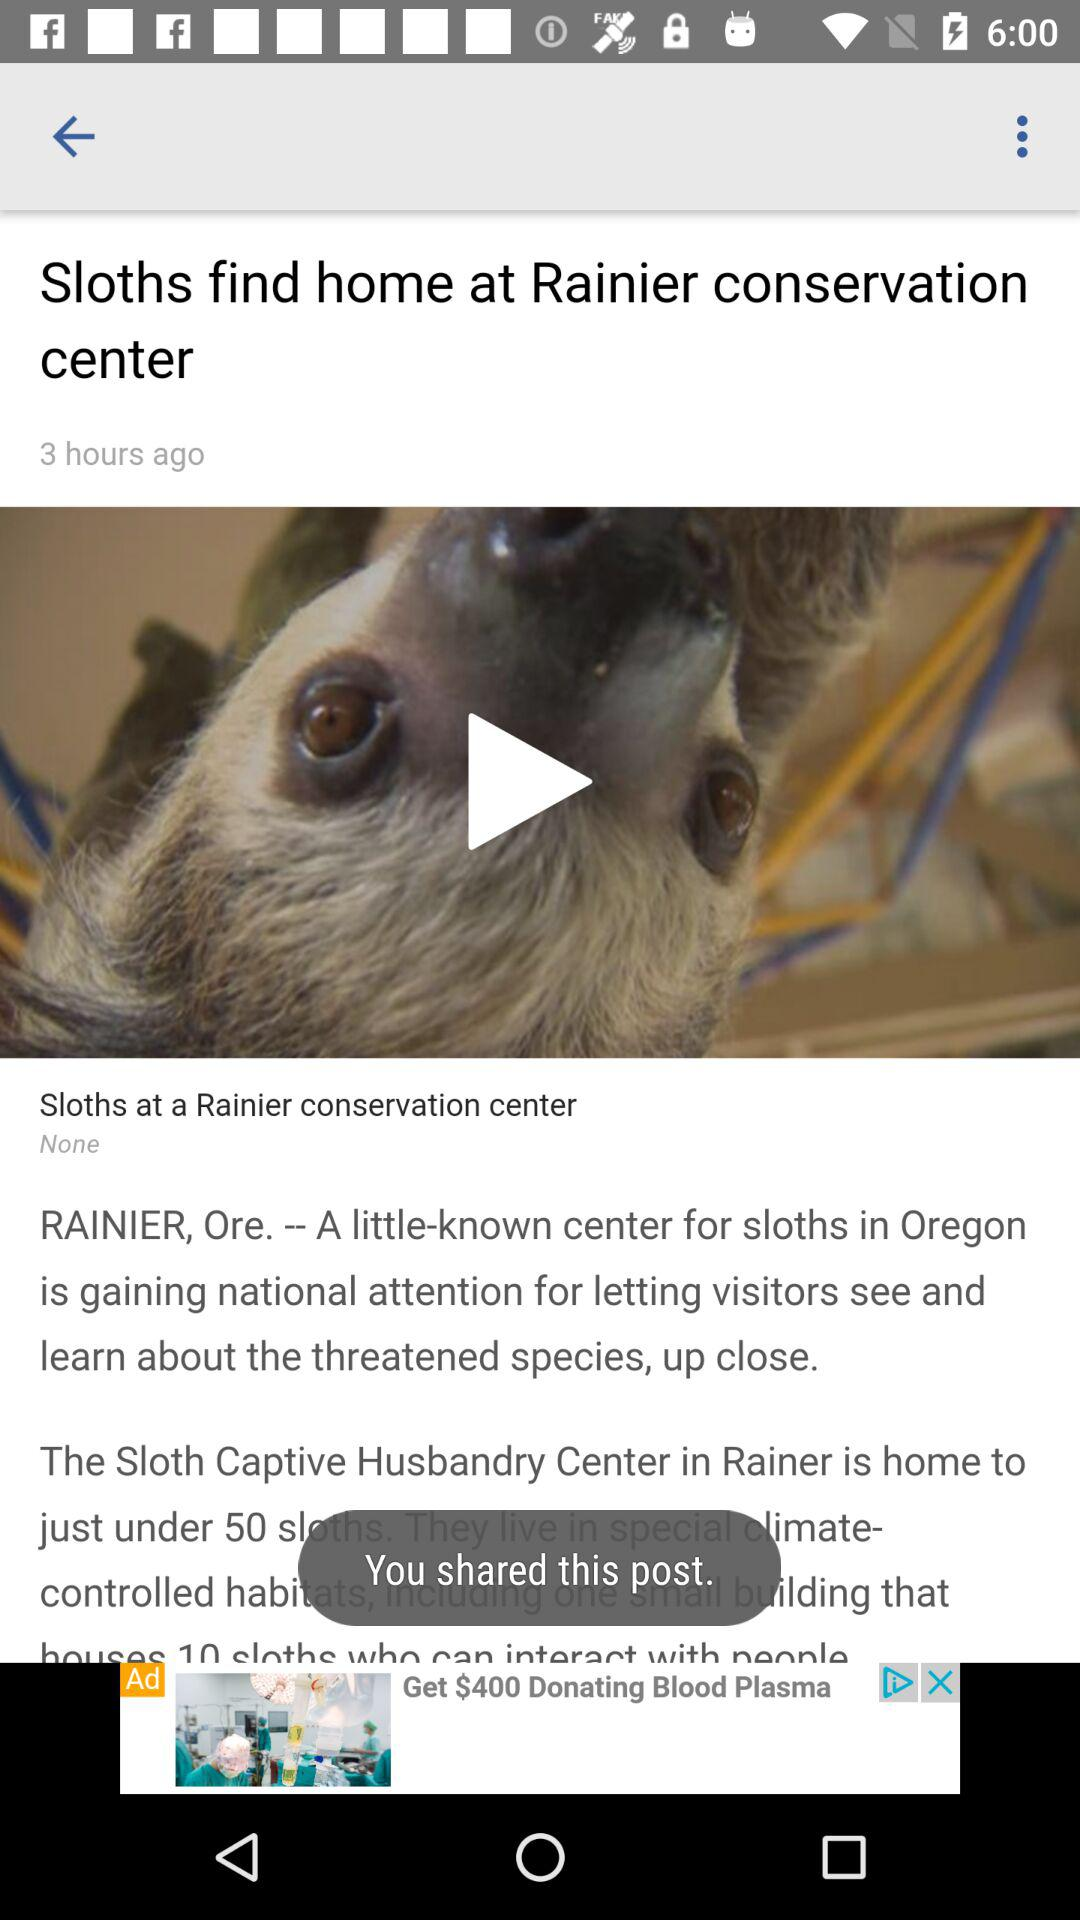How many more hours ago was the article published than the time on the screen?
Answer the question using a single word or phrase. 3 